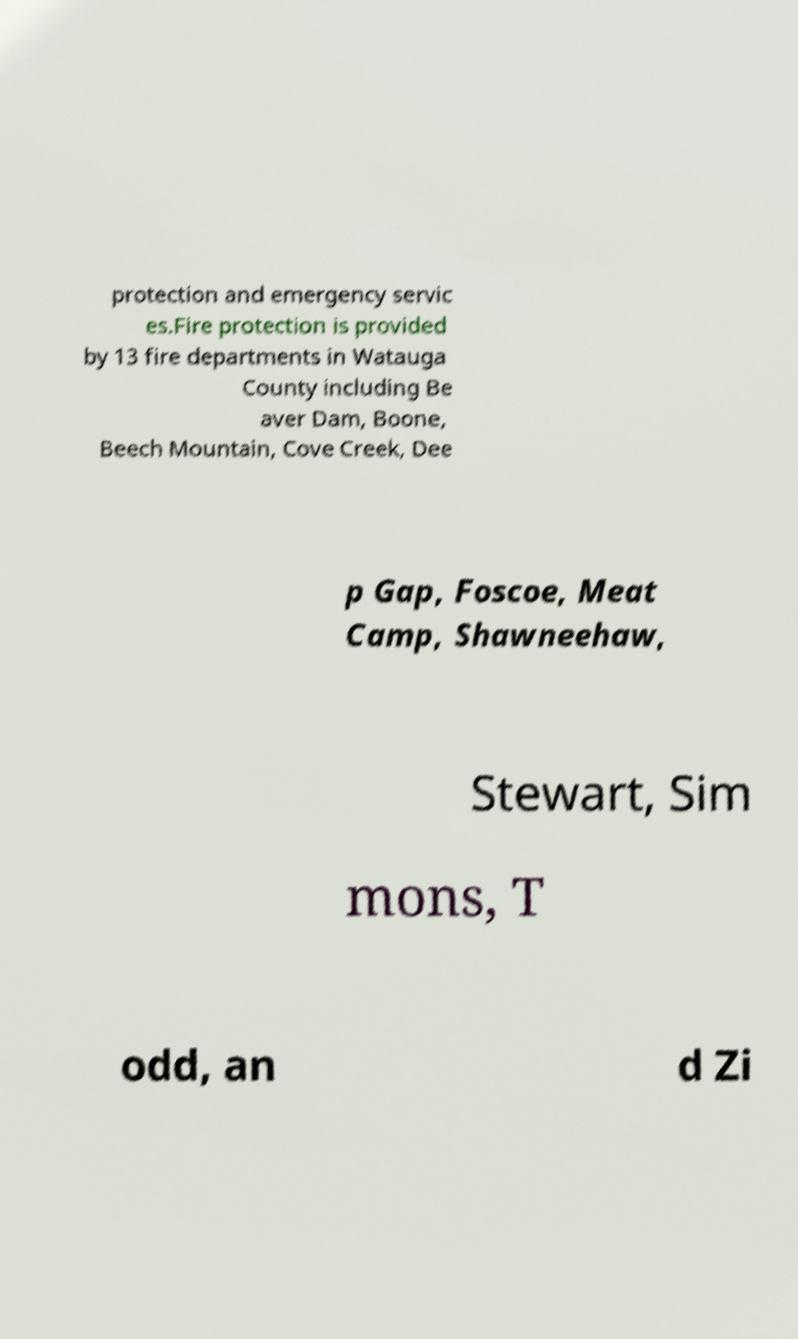Please read and relay the text visible in this image. What does it say? protection and emergency servic es.Fire protection is provided by 13 fire departments in Watauga County including Be aver Dam, Boone, Beech Mountain, Cove Creek, Dee p Gap, Foscoe, Meat Camp, Shawneehaw, Stewart, Sim mons, T odd, an d Zi 